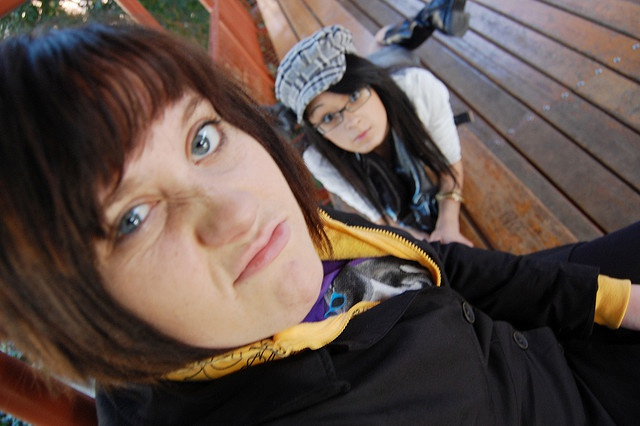Describe the objects in this image and their specific colors. I can see people in brown, black, tan, maroon, and gray tones, bench in brown, gray, and darkgray tones, and people in brown, black, darkgray, lightgray, and gray tones in this image. 